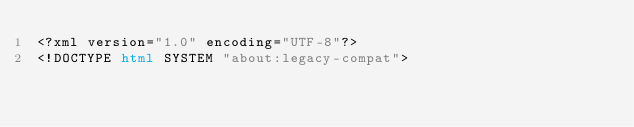<code> <loc_0><loc_0><loc_500><loc_500><_HTML_><?xml version="1.0" encoding="UTF-8"?>
<!DOCTYPE html SYSTEM "about:legacy-compat"></code> 